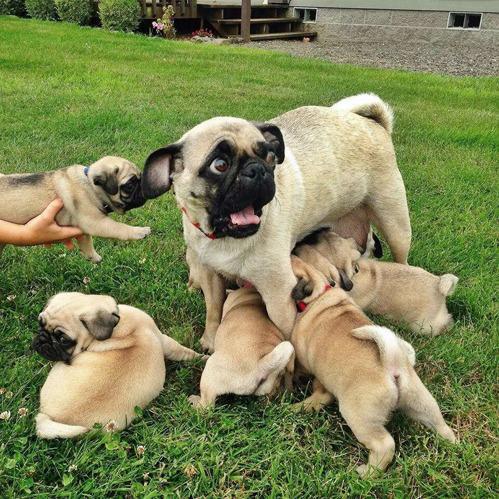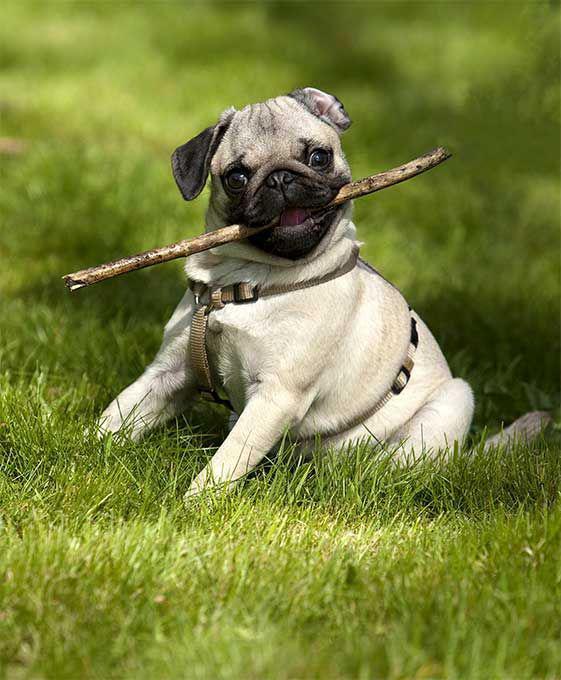The first image is the image on the left, the second image is the image on the right. Examine the images to the left and right. Is the description "In the image on the right, there is a dog with a stick in the dog's mouth." accurate? Answer yes or no. Yes. 